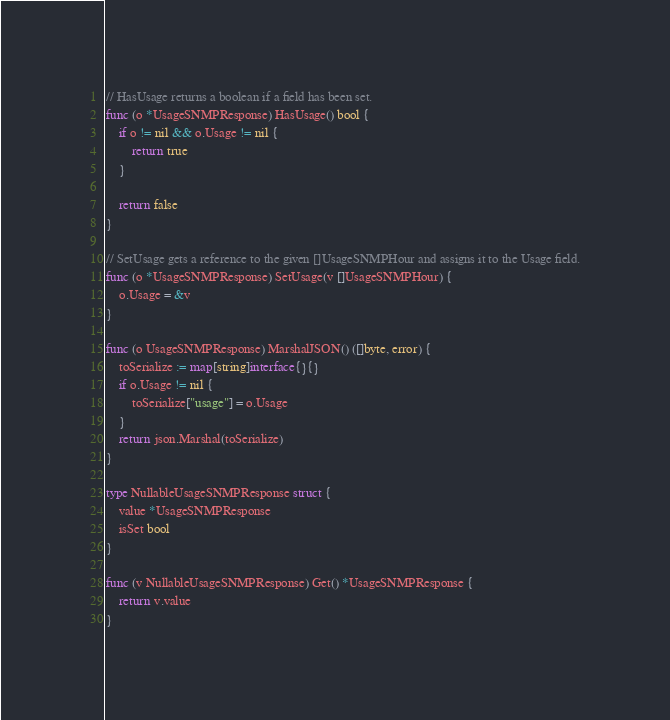<code> <loc_0><loc_0><loc_500><loc_500><_Go_>// HasUsage returns a boolean if a field has been set.
func (o *UsageSNMPResponse) HasUsage() bool {
	if o != nil && o.Usage != nil {
		return true
	}

	return false
}

// SetUsage gets a reference to the given []UsageSNMPHour and assigns it to the Usage field.
func (o *UsageSNMPResponse) SetUsage(v []UsageSNMPHour) {
	o.Usage = &v
}

func (o UsageSNMPResponse) MarshalJSON() ([]byte, error) {
	toSerialize := map[string]interface{}{}
	if o.Usage != nil {
		toSerialize["usage"] = o.Usage
	}
	return json.Marshal(toSerialize)
}

type NullableUsageSNMPResponse struct {
	value *UsageSNMPResponse
	isSet bool
}

func (v NullableUsageSNMPResponse) Get() *UsageSNMPResponse {
	return v.value
}
</code> 